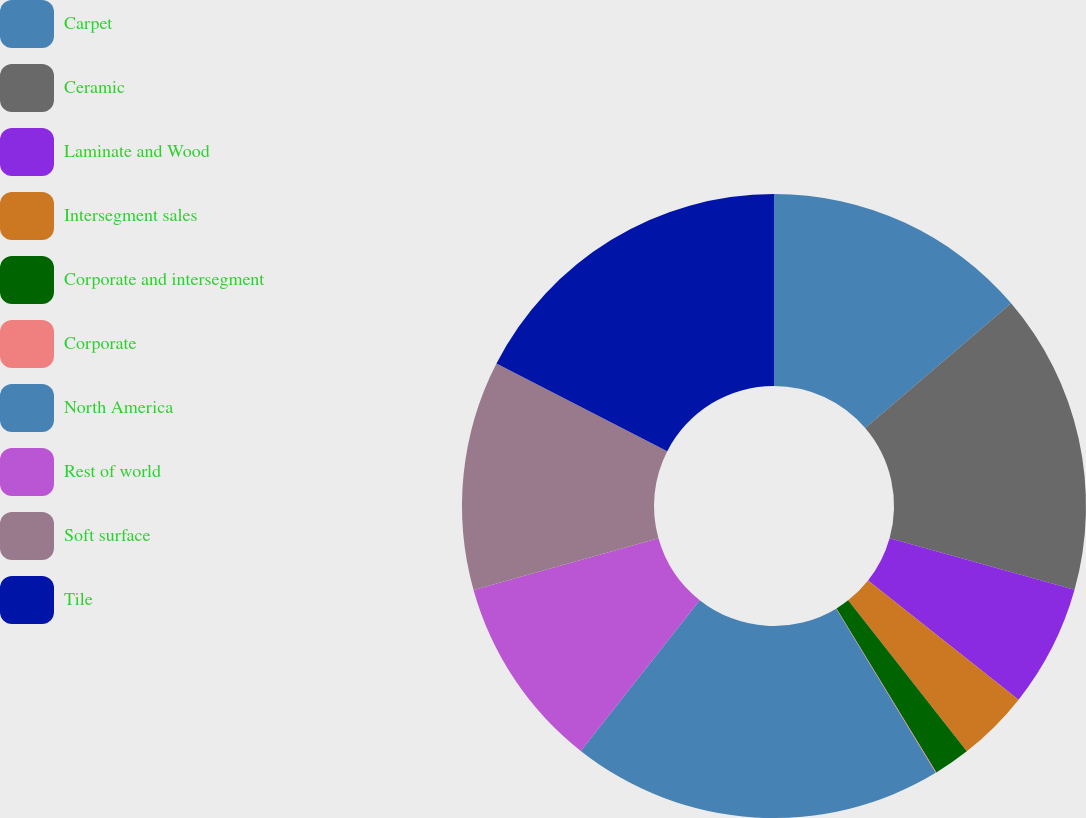Convert chart to OTSL. <chart><loc_0><loc_0><loc_500><loc_500><pie_chart><fcel>Carpet<fcel>Ceramic<fcel>Laminate and Wood<fcel>Intersegment sales<fcel>Corporate and intersegment<fcel>Corporate<fcel>North America<fcel>Rest of world<fcel>Soft surface<fcel>Tile<nl><fcel>13.74%<fcel>15.59%<fcel>6.33%<fcel>3.74%<fcel>1.89%<fcel>0.04%<fcel>19.3%<fcel>10.03%<fcel>11.89%<fcel>17.45%<nl></chart> 